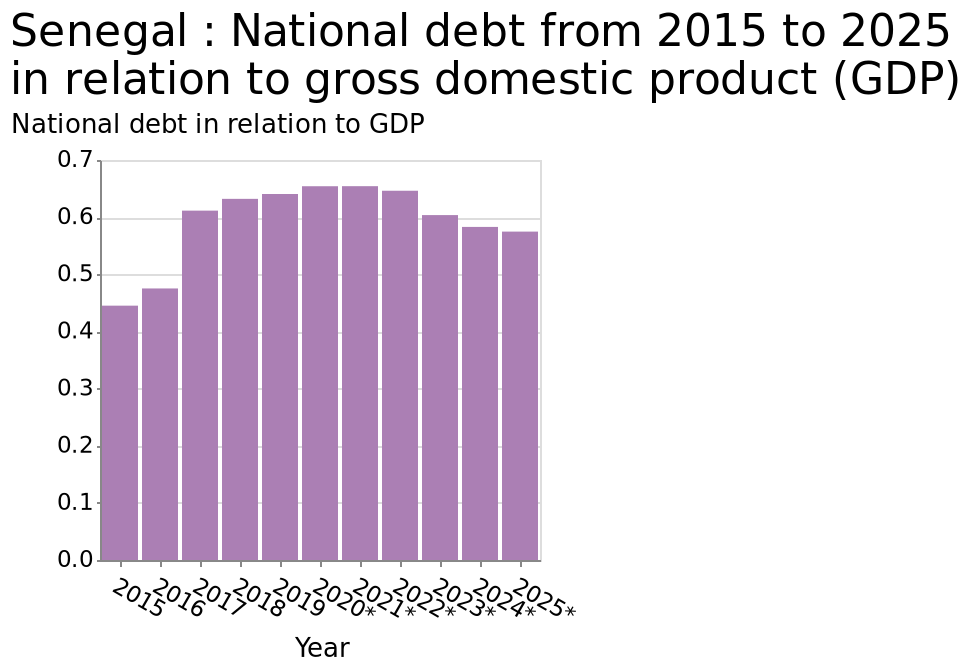<image>
What is the range of the y-axis in the bar diagram? The range of the y-axis in the bar diagram is from 0.0 to 0.7. What happened to the national debt in Senegal?  The national debt in Senegal rose a little before falling back a bit. Offer a thorough analysis of the image. National debt in Senegal rose a little before falling back a bit. 